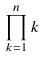Convert formula to latex. <formula><loc_0><loc_0><loc_500><loc_500>\prod _ { k = 1 } ^ { n } k</formula> 